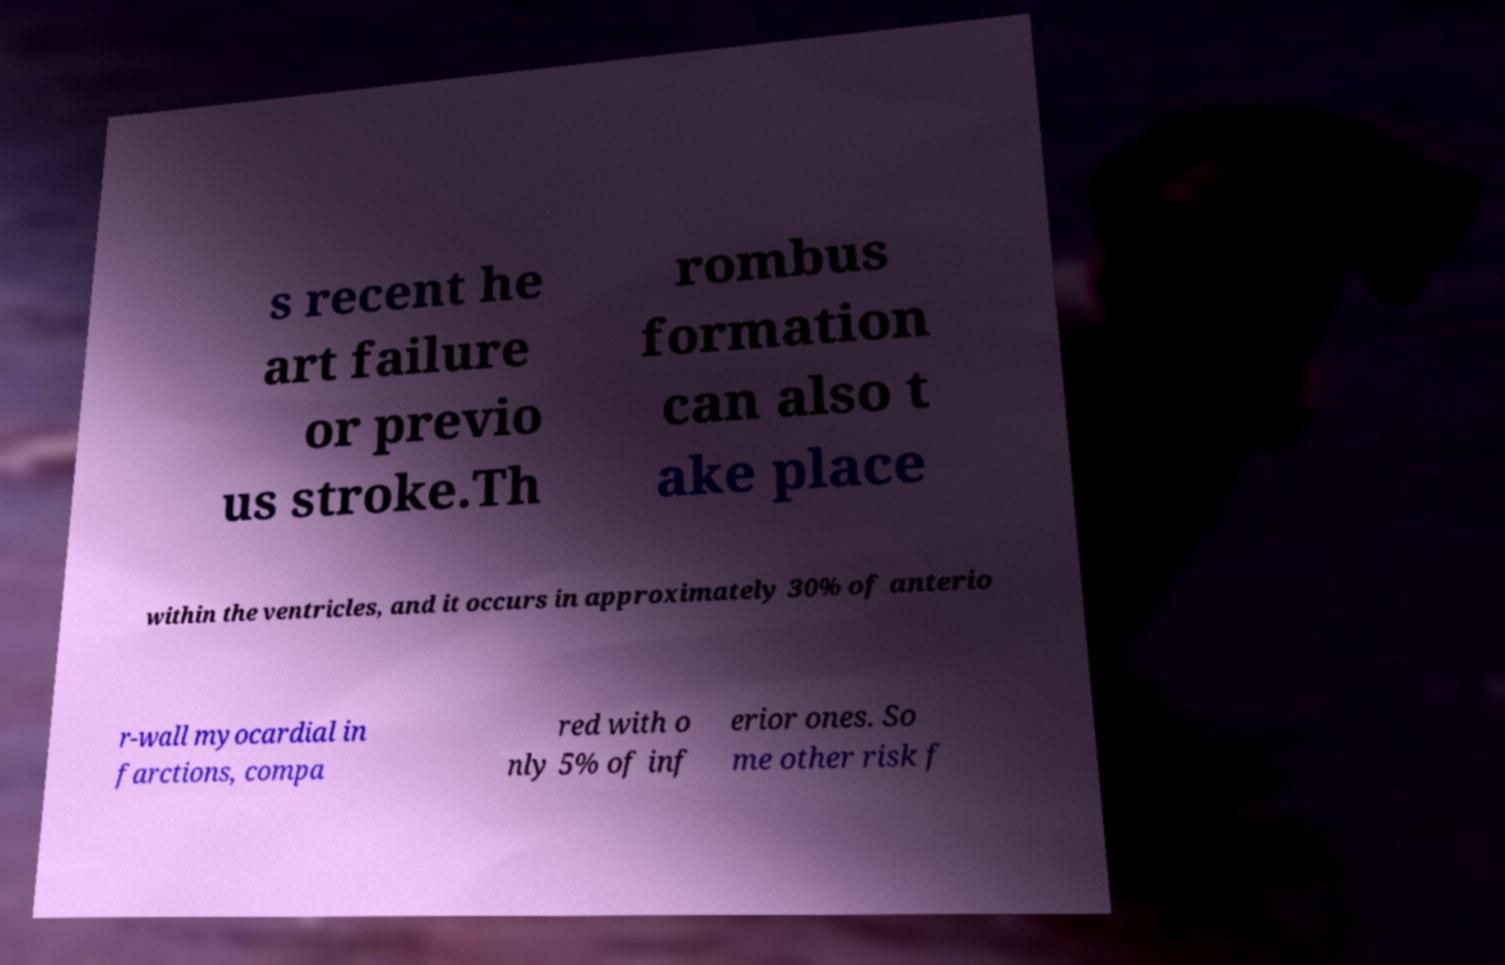Please read and relay the text visible in this image. What does it say? s recent he art failure or previo us stroke.Th rombus formation can also t ake place within the ventricles, and it occurs in approximately 30% of anterio r-wall myocardial in farctions, compa red with o nly 5% of inf erior ones. So me other risk f 